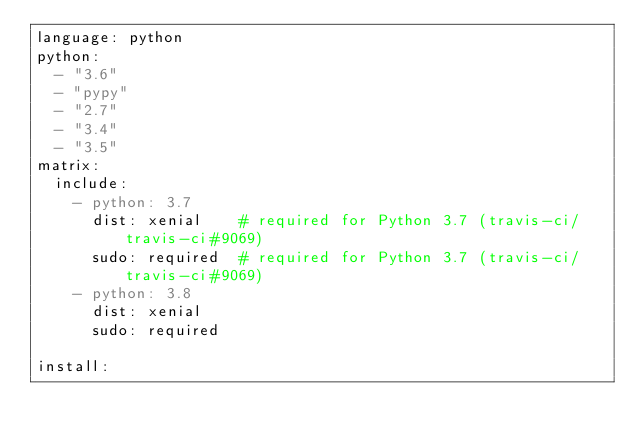Convert code to text. <code><loc_0><loc_0><loc_500><loc_500><_YAML_>language: python
python:
  - "3.6"
  - "pypy"
  - "2.7"
  - "3.4"
  - "3.5"
matrix:
  include:
    - python: 3.7
      dist: xenial    # required for Python 3.7 (travis-ci/travis-ci#9069)
      sudo: required  # required for Python 3.7 (travis-ci/travis-ci#9069)
    - python: 3.8
      dist: xenial
      sudo: required

install:</code> 